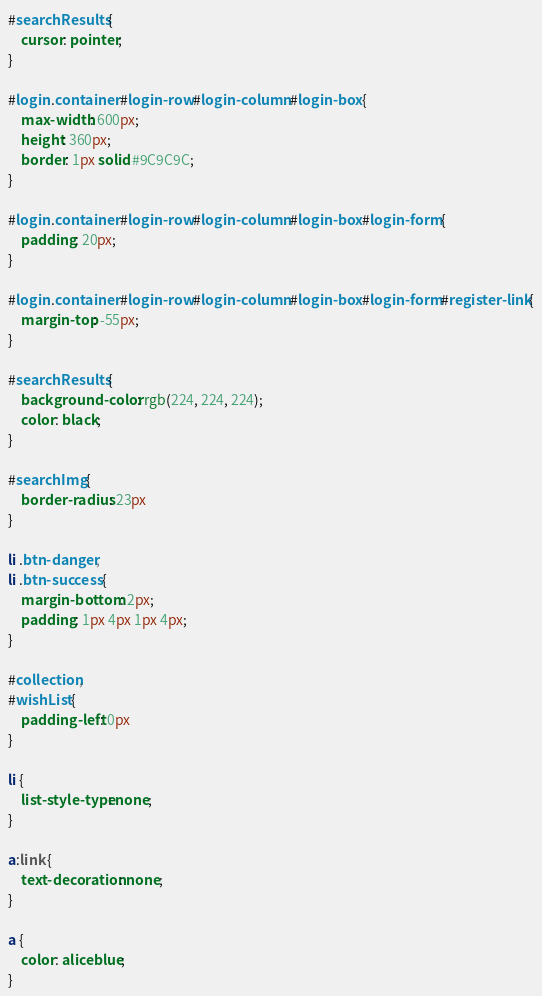Convert code to text. <code><loc_0><loc_0><loc_500><loc_500><_CSS_>#searchResults {
    cursor: pointer;
}

#login .container #login-row #login-column #login-box {
    max-width: 600px;
    height: 360px;
    border: 1px solid #9C9C9C;
}

#login .container #login-row #login-column #login-box #login-form {
    padding: 20px;
}

#login .container #login-row #login-column #login-box #login-form #register-link {
    margin-top: -55px;
}

#searchResults {
    background-color: rgb(224, 224, 224);
    color: black;
}

#searchImg {
    border-radius: 23px
}

li .btn-danger,
li .btn-success {
    margin-bottom: 2px;
    padding: 1px 4px 1px 4px;
}

#collection,
#wishList {
    padding-left: 0px
}

li {
    list-style-type: none;
}

a:link {
    text-decoration: none;
}

a {
    color: aliceblue;
}</code> 